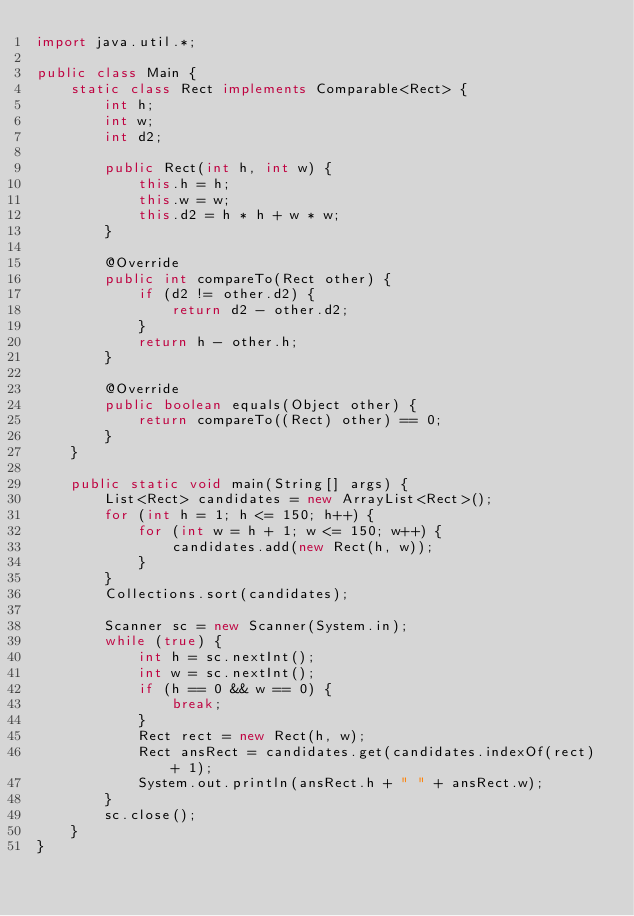<code> <loc_0><loc_0><loc_500><loc_500><_Java_>import java.util.*;

public class Main {
    static class Rect implements Comparable<Rect> {
        int h;
        int w;
        int d2;

        public Rect(int h, int w) {
            this.h = h;
            this.w = w;
            this.d2 = h * h + w * w;
        }

        @Override
        public int compareTo(Rect other) {
            if (d2 != other.d2) {
                return d2 - other.d2;
            }
            return h - other.h;
        }

        @Override
        public boolean equals(Object other) {
            return compareTo((Rect) other) == 0;
        }
    }

    public static void main(String[] args) {
        List<Rect> candidates = new ArrayList<Rect>();
        for (int h = 1; h <= 150; h++) {
            for (int w = h + 1; w <= 150; w++) {
                candidates.add(new Rect(h, w));
            }
        }
        Collections.sort(candidates);

        Scanner sc = new Scanner(System.in);
        while (true) {
            int h = sc.nextInt();
            int w = sc.nextInt();
            if (h == 0 && w == 0) {
                break;
            }
            Rect rect = new Rect(h, w);
            Rect ansRect = candidates.get(candidates.indexOf(rect) + 1);
            System.out.println(ansRect.h + " " + ansRect.w);
        }
        sc.close();
    }
}</code> 